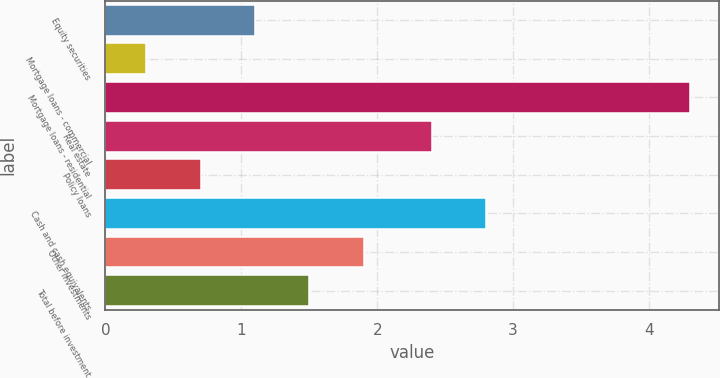Convert chart. <chart><loc_0><loc_0><loc_500><loc_500><bar_chart><fcel>Equity securities<fcel>Mortgage loans - commercial<fcel>Mortgage loans - residential<fcel>Real estate<fcel>Policy loans<fcel>Cash and cash equivalents<fcel>Other investments<fcel>Total before investment<nl><fcel>1.1<fcel>0.3<fcel>4.3<fcel>2.4<fcel>0.7<fcel>2.8<fcel>1.9<fcel>1.5<nl></chart> 